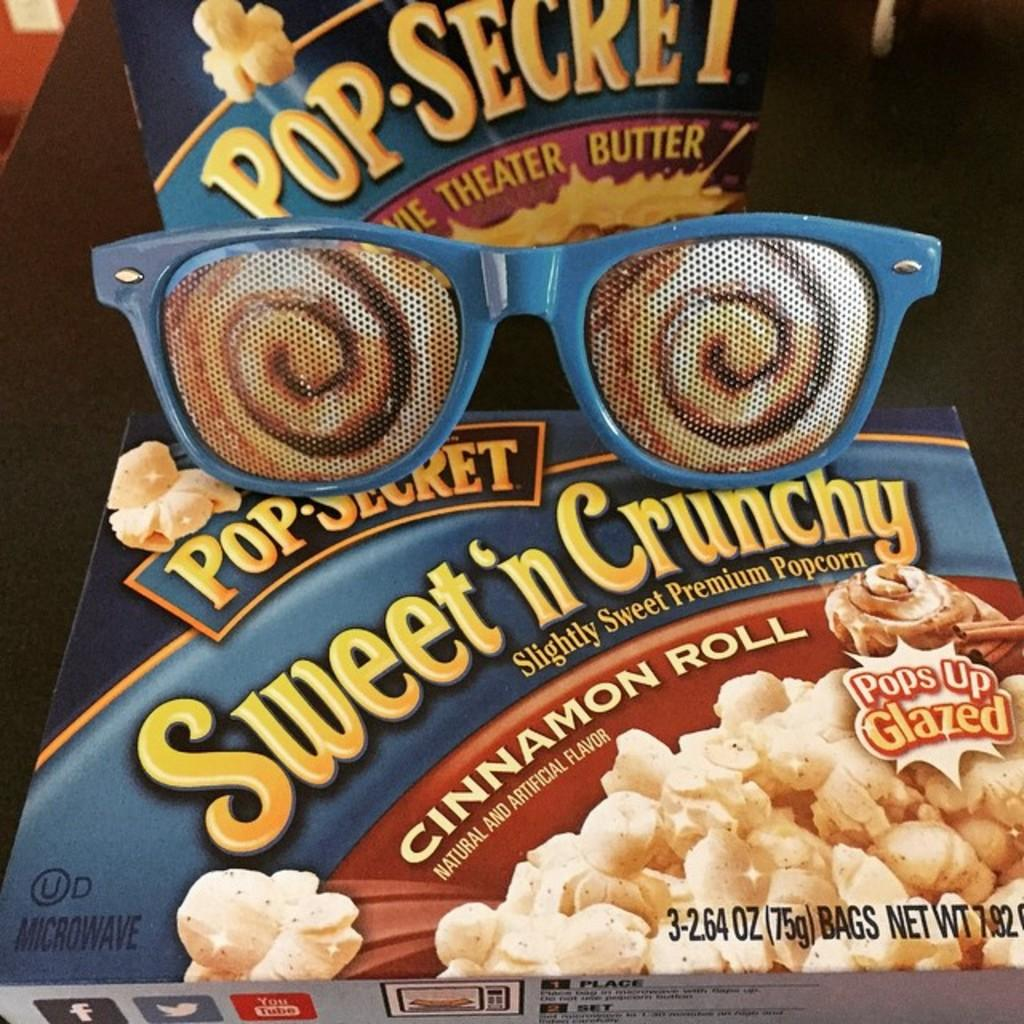What type of snack item box is in the image? The specific type of snack item box is not mentioned, but there is a snack item box in the image. What other item can be seen in the image? There are goggles in the image. Where are the snack item box and goggles located? Both the snack item box and goggles are on a table. What theory is being discussed in the image? There is no discussion or theory present in the image; it features a snack item box and goggles on a table. How does the person in the image get into trouble? There is no person present in the image, so it is not possible to determine if they are getting into trouble. 